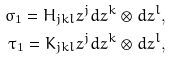<formula> <loc_0><loc_0><loc_500><loc_500>\sigma _ { 1 } = H _ { j k l } z ^ { j } d z ^ { k } \otimes d z ^ { l } , \\ \tau _ { 1 } = K _ { j k l } z ^ { j } d z ^ { k } \otimes d z ^ { l } ,</formula> 